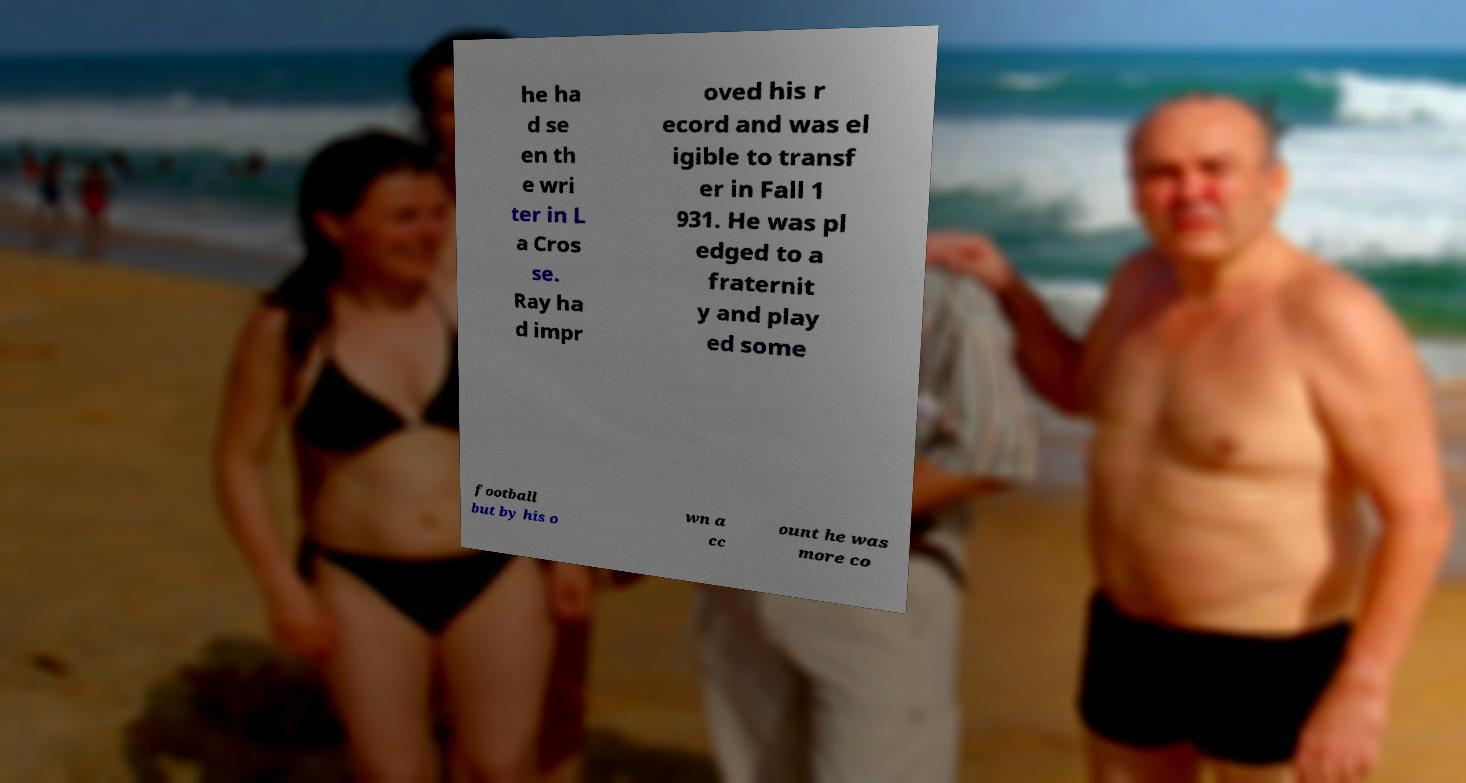For documentation purposes, I need the text within this image transcribed. Could you provide that? he ha d se en th e wri ter in L a Cros se. Ray ha d impr oved his r ecord and was el igible to transf er in Fall 1 931. He was pl edged to a fraternit y and play ed some football but by his o wn a cc ount he was more co 